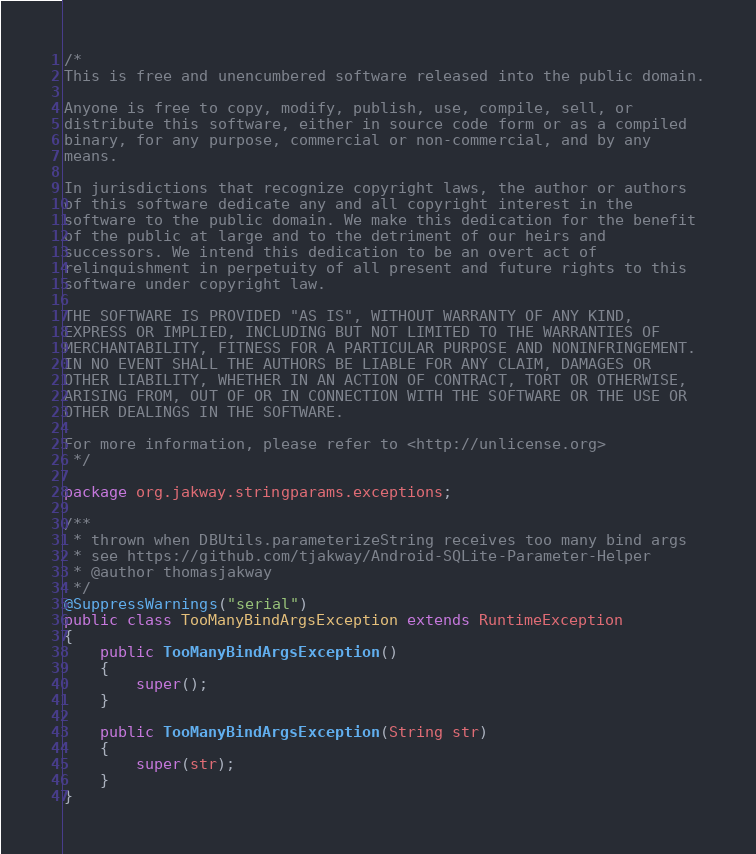<code> <loc_0><loc_0><loc_500><loc_500><_Java_>/*
This is free and unencumbered software released into the public domain.

Anyone is free to copy, modify, publish, use, compile, sell, or
distribute this software, either in source code form or as a compiled
binary, for any purpose, commercial or non-commercial, and by any
means.

In jurisdictions that recognize copyright laws, the author or authors
of this software dedicate any and all copyright interest in the
software to the public domain. We make this dedication for the benefit
of the public at large and to the detriment of our heirs and
successors. We intend this dedication to be an overt act of
relinquishment in perpetuity of all present and future rights to this
software under copyright law.

THE SOFTWARE IS PROVIDED "AS IS", WITHOUT WARRANTY OF ANY KIND,
EXPRESS OR IMPLIED, INCLUDING BUT NOT LIMITED TO THE WARRANTIES OF
MERCHANTABILITY, FITNESS FOR A PARTICULAR PURPOSE AND NONINFRINGEMENT.
IN NO EVENT SHALL THE AUTHORS BE LIABLE FOR ANY CLAIM, DAMAGES OR
OTHER LIABILITY, WHETHER IN AN ACTION OF CONTRACT, TORT OR OTHERWISE,
ARISING FROM, OUT OF OR IN CONNECTION WITH THE SOFTWARE OR THE USE OR
OTHER DEALINGS IN THE SOFTWARE.

For more information, please refer to <http://unlicense.org>
 */

package org.jakway.stringparams.exceptions;

/**
 * thrown when DBUtils.parameterizeString receives too many bind args
 * see https://github.com/tjakway/Android-SQLite-Parameter-Helper
 * @author thomasjakway
 */
@SuppressWarnings("serial")
public class TooManyBindArgsException extends RuntimeException
{
	public TooManyBindArgsException()
	{
		super();
	}
	
	public TooManyBindArgsException(String str)
	{
		super(str);
	}
}
</code> 